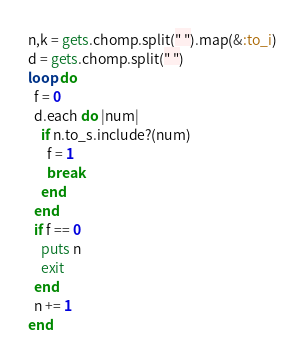<code> <loc_0><loc_0><loc_500><loc_500><_Ruby_>n,k = gets.chomp.split(" ").map(&:to_i)
d = gets.chomp.split(" ")
loop do
  f = 0
  d.each do |num|
    if n.to_s.include?(num)
      f = 1
      break
    end
  end
  if f == 0
    puts n
    exit
  end
  n += 1
end</code> 